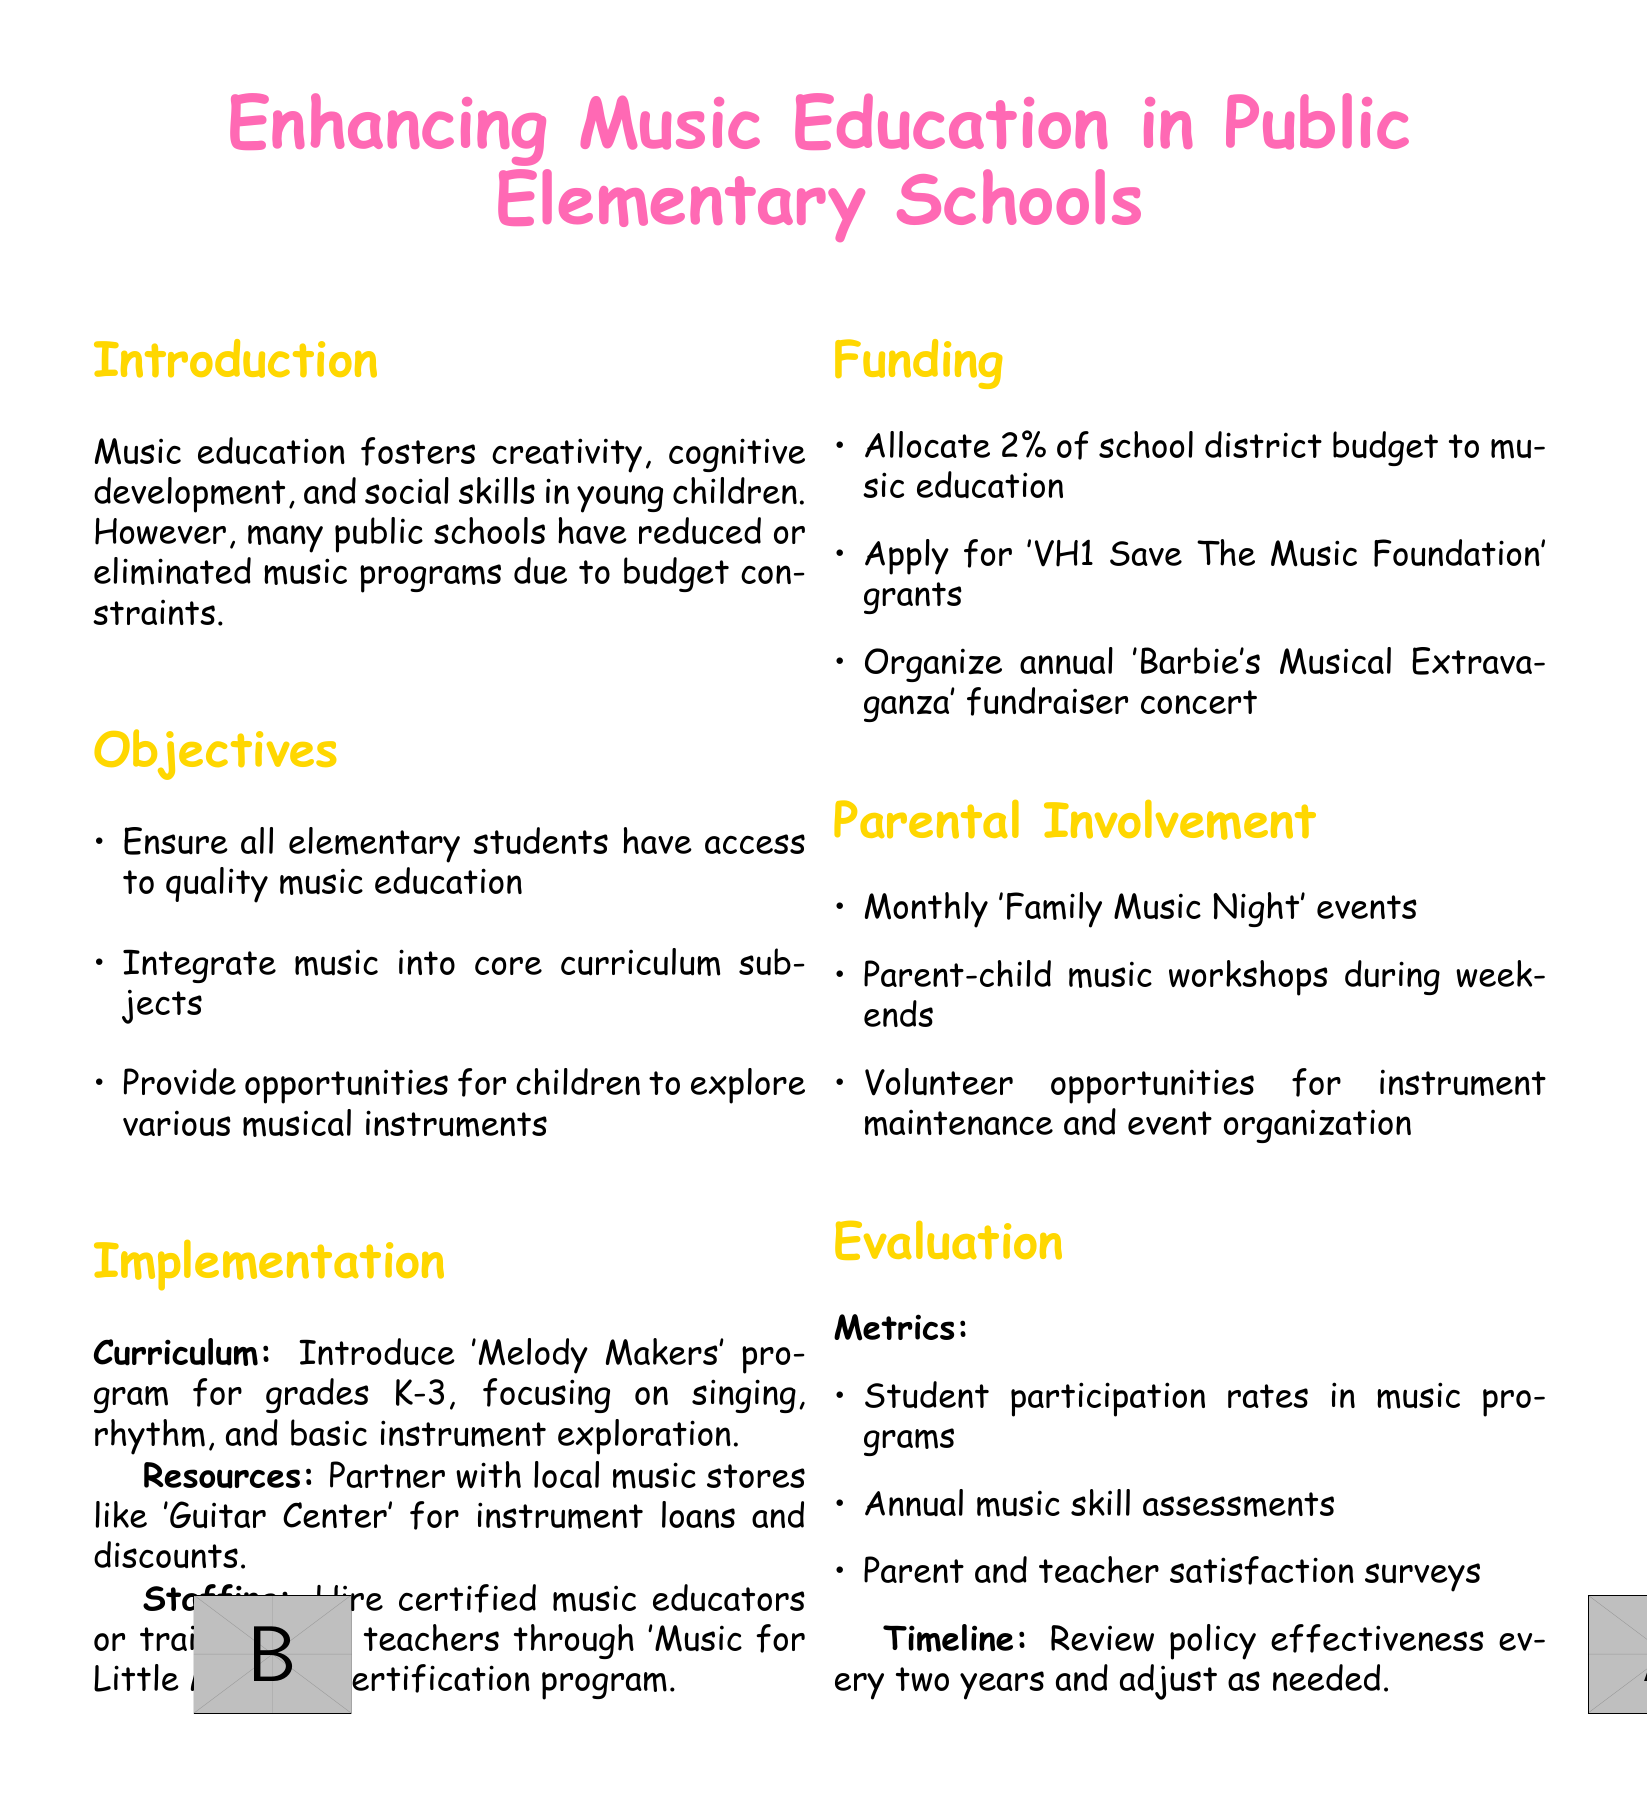What is the title of the document? The title introduces the main focus of the policy document.
Answer: Enhancing Music Education in Public Elementary Schools What grade levels does the 'Melody Makers' program target? The document specifies the grade levels for the music program.
Answer: K-3 What percentage of the school district budget is allocated to music education? The funding section outlines the budget allocation for music programs.
Answer: 2% What type of events are organized for parental involvement? The document lists activities designed to engage parents in the music education process.
Answer: Family Music Night What is the aim of the 'VH1 Save The Music Foundation'? This foundation is mentioned as a source of funding for music education, indicating its purpose.
Answer: Grants What is evaluated every two years according to the policy? The document specifies what aspect of the program will undergo evaluation at regular intervals.
Answer: Policy effectiveness What is one of the objectives of the music education policy? The document outlines key goals of the program.
Answer: Access to quality music education Who can partner with schools for instrument loans? The resources section mentions potential partners for supporting music education.
Answer: Guitar Center 